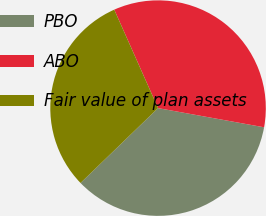Convert chart. <chart><loc_0><loc_0><loc_500><loc_500><pie_chart><fcel>PBO<fcel>ABO<fcel>Fair value of plan assets<nl><fcel>34.93%<fcel>34.51%<fcel>30.56%<nl></chart> 